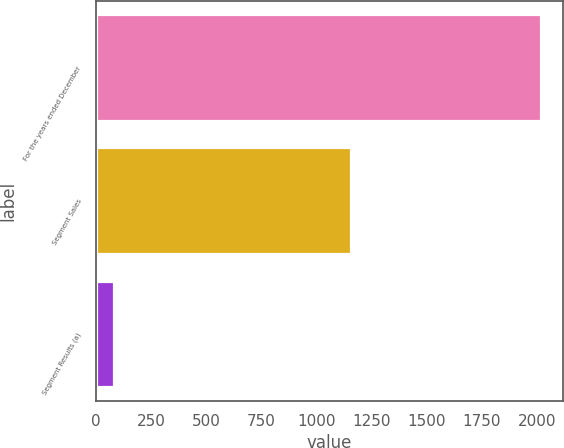Convert chart to OTSL. <chart><loc_0><loc_0><loc_500><loc_500><bar_chart><fcel>For the years ended December<fcel>Segment Sales<fcel>Segment Results (a)<nl><fcel>2017<fcel>1157<fcel>85<nl></chart> 